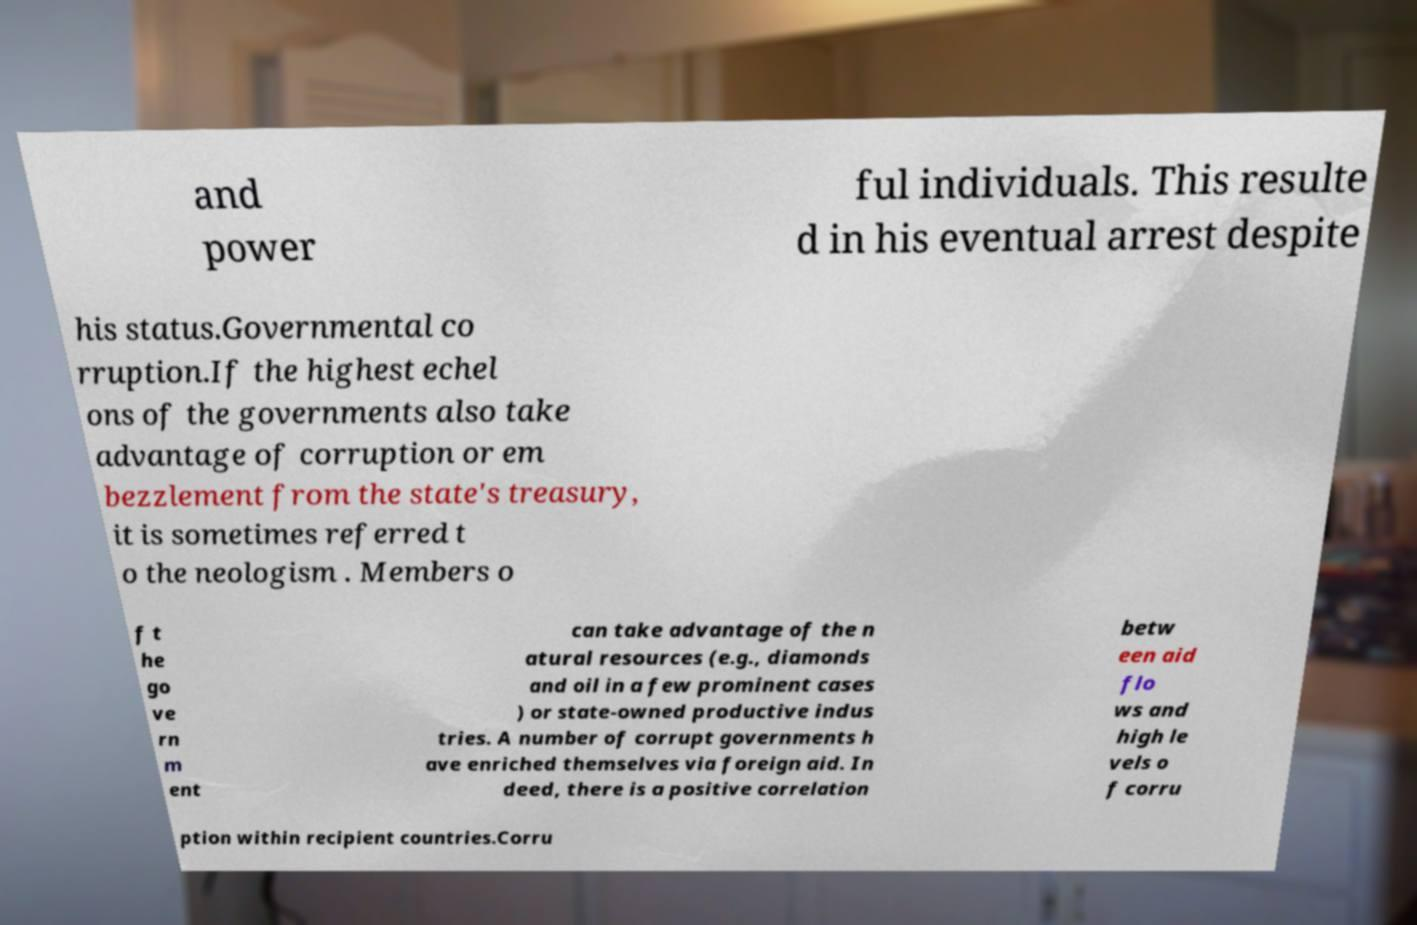Please identify and transcribe the text found in this image. and power ful individuals. This resulte d in his eventual arrest despite his status.Governmental co rruption.If the highest echel ons of the governments also take advantage of corruption or em bezzlement from the state's treasury, it is sometimes referred t o the neologism . Members o f t he go ve rn m ent can take advantage of the n atural resources (e.g., diamonds and oil in a few prominent cases ) or state-owned productive indus tries. A number of corrupt governments h ave enriched themselves via foreign aid. In deed, there is a positive correlation betw een aid flo ws and high le vels o f corru ption within recipient countries.Corru 